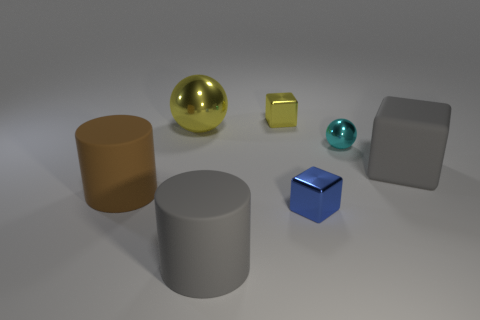Looking at the arrangement, is there any pattern or symmetry? The arrangement of the objects doesn't follow a clear symmetric pattern; however, it appears deliberate and balanced. The objects are placed in a loose grouping towards the center of the image, with varying distances between them, providing a composition that is aesthetically pleasing and draws the eye across the scene. 